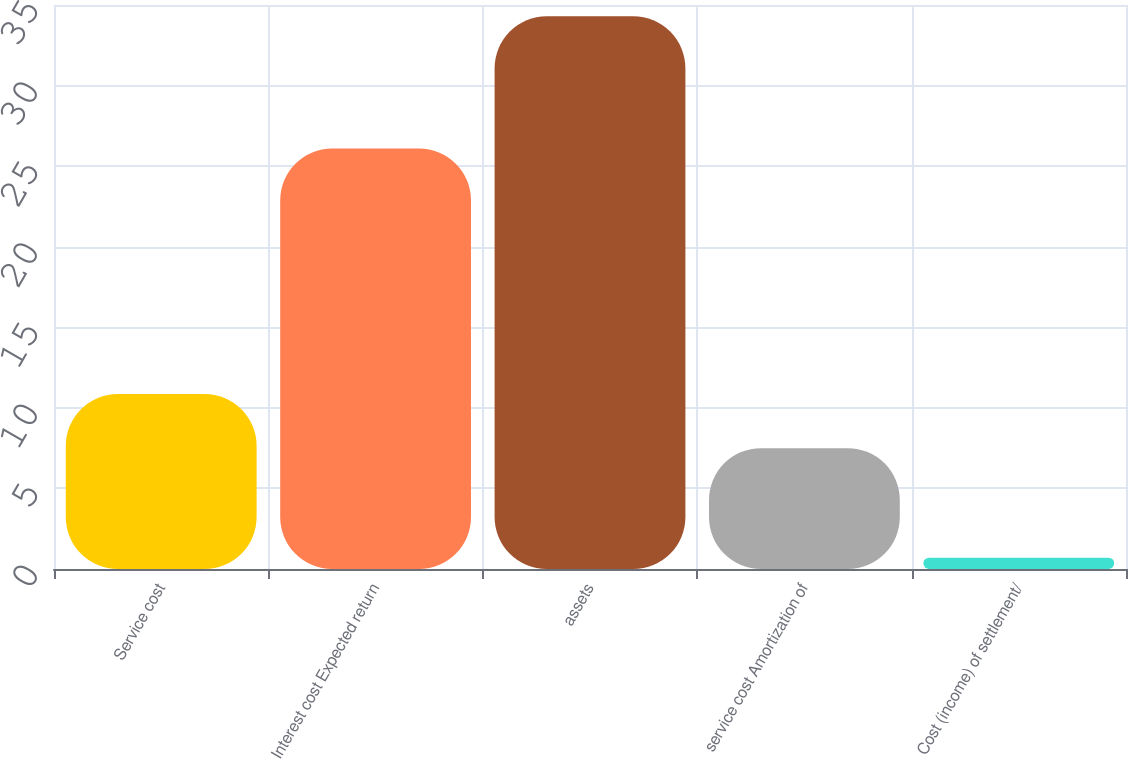Convert chart to OTSL. <chart><loc_0><loc_0><loc_500><loc_500><bar_chart><fcel>Service cost<fcel>Interest cost Expected return<fcel>assets<fcel>service cost Amortization of<fcel>Cost (income) of settlement/<nl><fcel>10.86<fcel>26.1<fcel>34.3<fcel>7.5<fcel>0.7<nl></chart> 